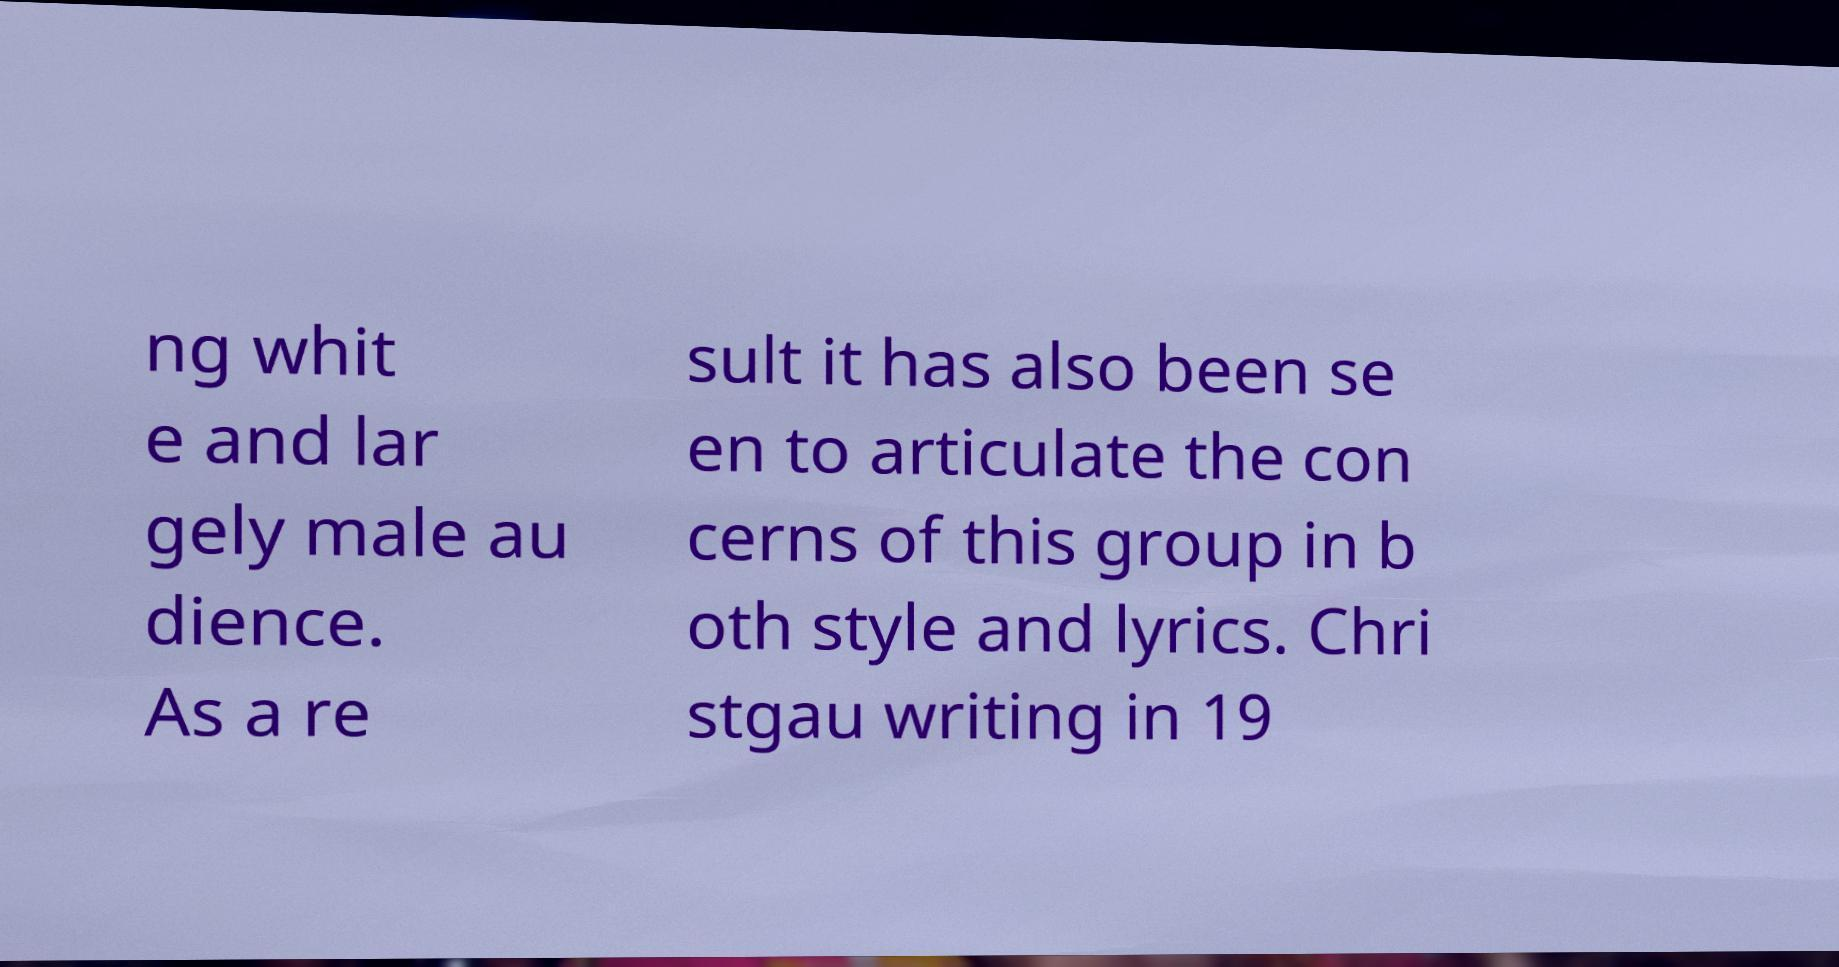I need the written content from this picture converted into text. Can you do that? ng whit e and lar gely male au dience. As a re sult it has also been se en to articulate the con cerns of this group in b oth style and lyrics. Chri stgau writing in 19 